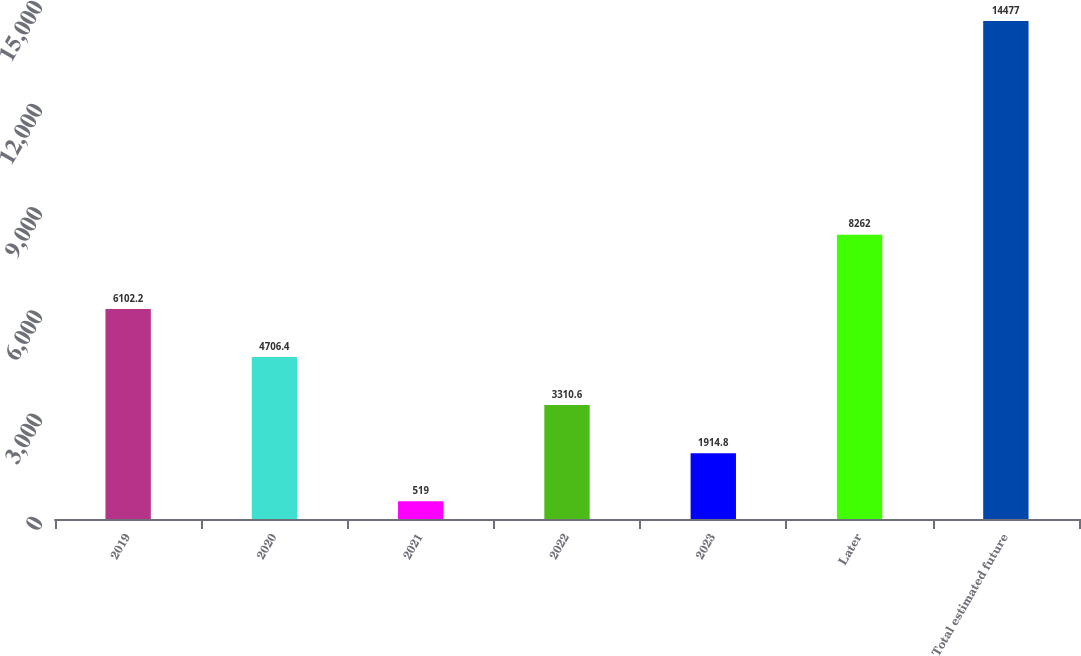Convert chart. <chart><loc_0><loc_0><loc_500><loc_500><bar_chart><fcel>2019<fcel>2020<fcel>2021<fcel>2022<fcel>2023<fcel>Later<fcel>Total estimated future<nl><fcel>6102.2<fcel>4706.4<fcel>519<fcel>3310.6<fcel>1914.8<fcel>8262<fcel>14477<nl></chart> 